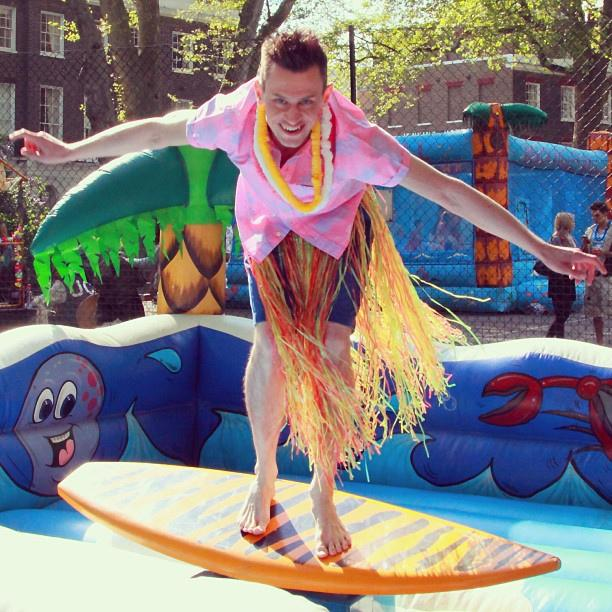What kind of animal is the cartoon face on the left?

Choices:
A) octopus
B) shark
C) bear
D) seal octopus 